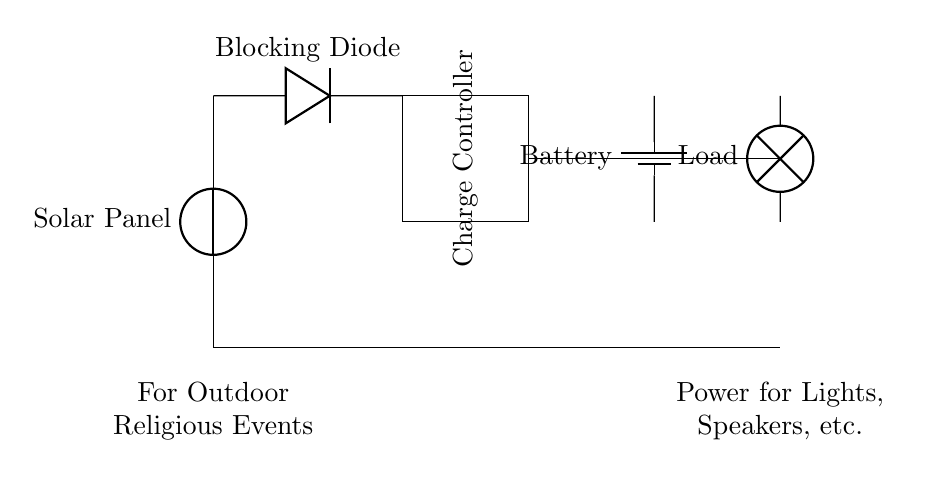What is the primary function of the solar panel in this circuit? The solar panel's primary function is to convert solar energy into electrical energy for charging the battery.
Answer: convert solar energy What component prevents reverse current flow? The blocking diode prevents reverse current flow, ensuring that current only flows from the solar panel to the battery and not back.
Answer: blocking diode How many main components are depicted in this circuit? The diagram shows four main components: the solar panel, blocking diode, charge controller, and battery.
Answer: four What does the charge controller do in this circuit? The charge controller regulates the voltage and current coming from the solar panel to ensure safe charging of the battery.
Answer: regulate voltage and current Which component provides power to the load? The battery provides power to the load, which can include lights, speakers, etc.
Answer: battery How does the current flow from the solar panel to the load? The current flows from the solar panel to the blocking diode, then to the charge controller, which directs it to the battery and finally to the load.
Answer: through the blocking diode and charge controller What type of events is this circuit designed for? This circuit is specifically designed for outdoor religious events where power for lights and speakers is required.
Answer: outdoor religious events 